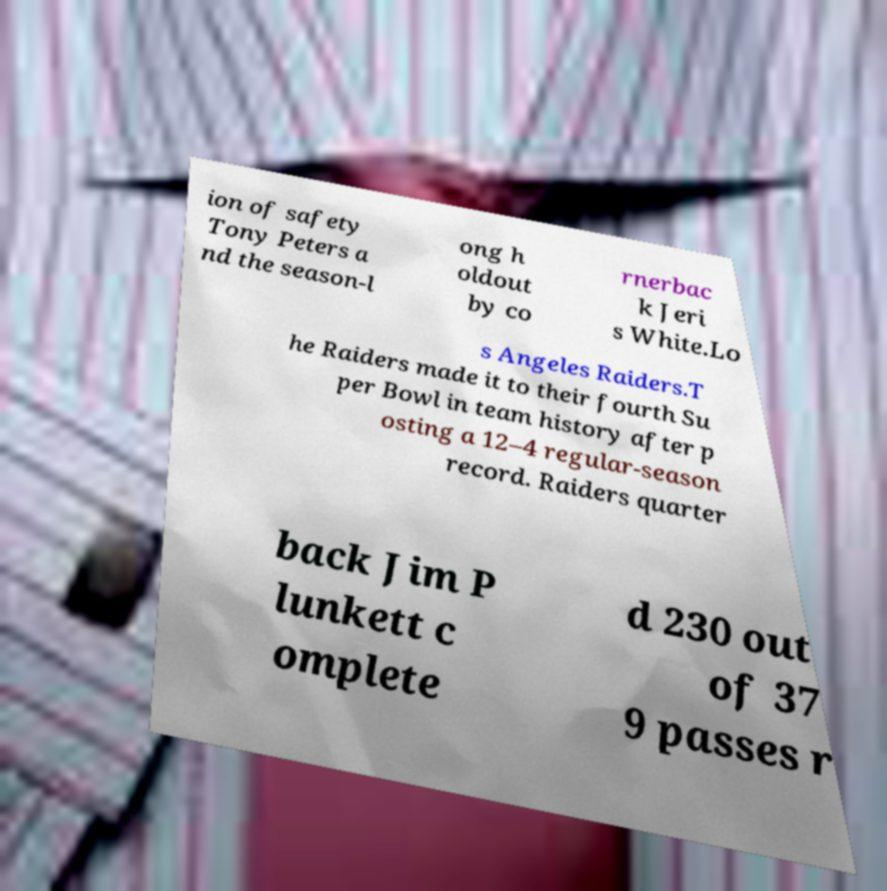Can you accurately transcribe the text from the provided image for me? ion of safety Tony Peters a nd the season-l ong h oldout by co rnerbac k Jeri s White.Lo s Angeles Raiders.T he Raiders made it to their fourth Su per Bowl in team history after p osting a 12–4 regular-season record. Raiders quarter back Jim P lunkett c omplete d 230 out of 37 9 passes r 